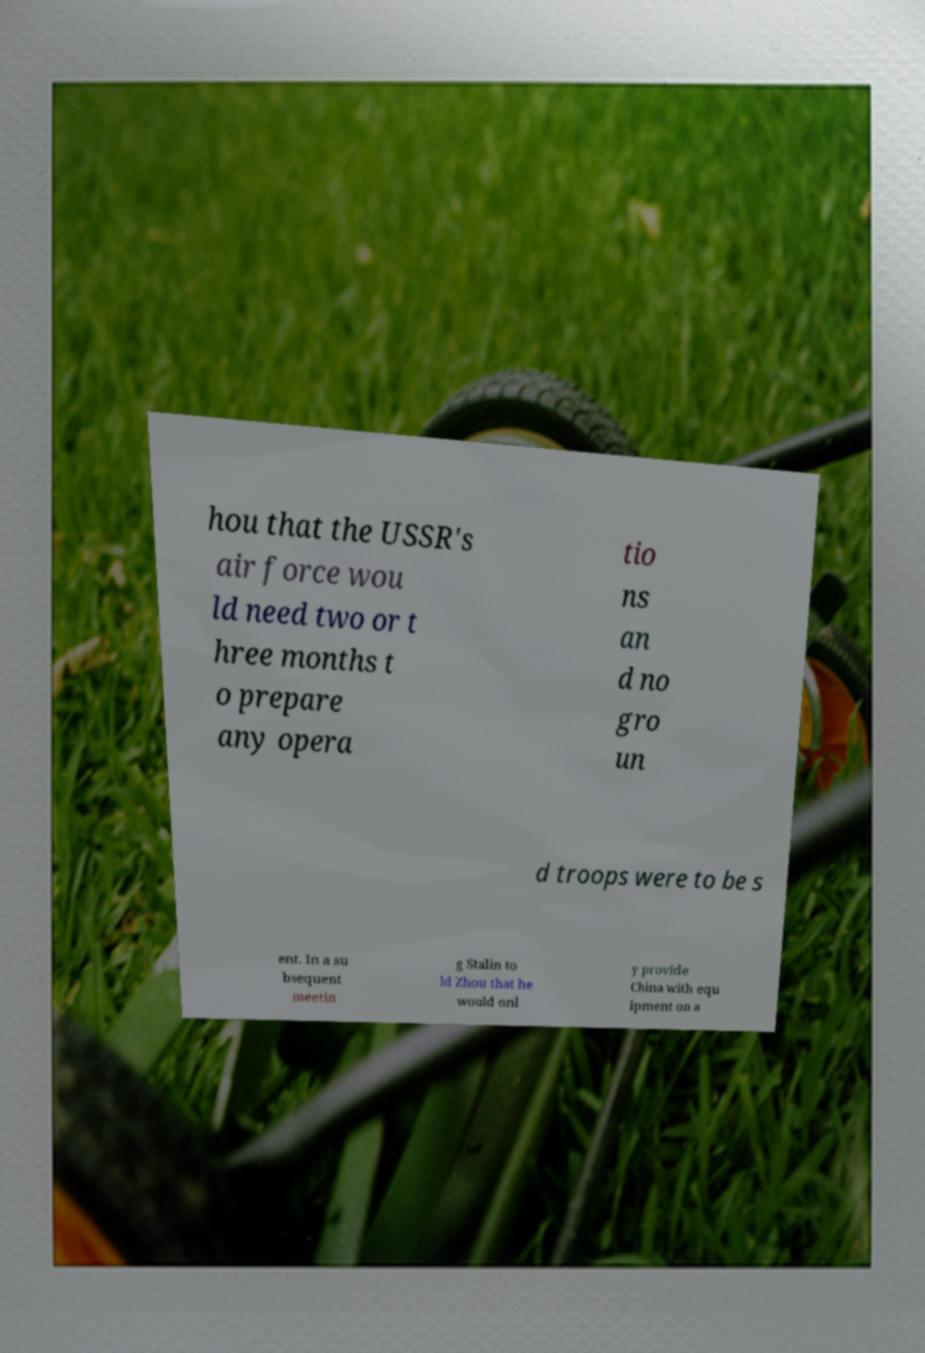There's text embedded in this image that I need extracted. Can you transcribe it verbatim? hou that the USSR's air force wou ld need two or t hree months t o prepare any opera tio ns an d no gro un d troops were to be s ent. In a su bsequent meetin g Stalin to ld Zhou that he would onl y provide China with equ ipment on a 